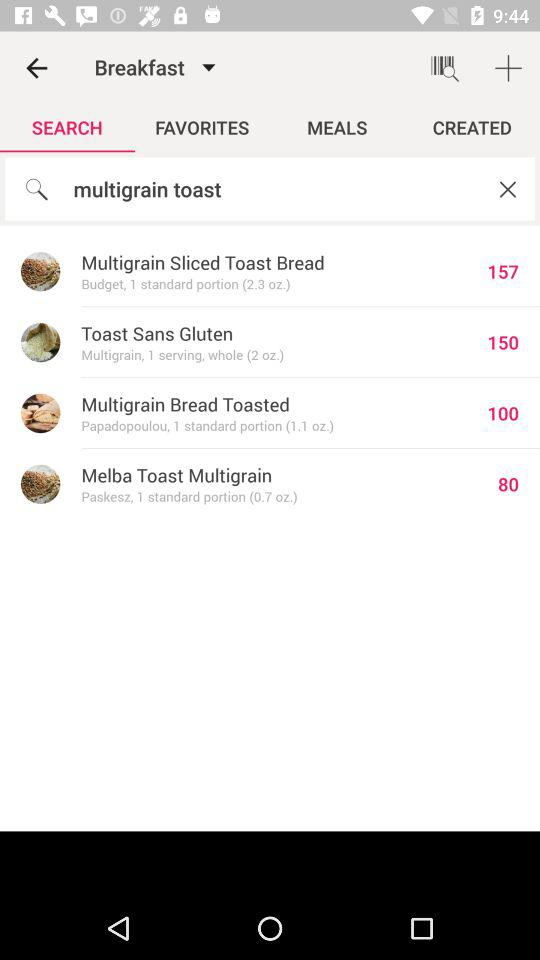How many more grams of protein are in the Multigrain Bread Toasted than the Melba Toast Multigrain?
Answer the question using a single word or phrase. 20 